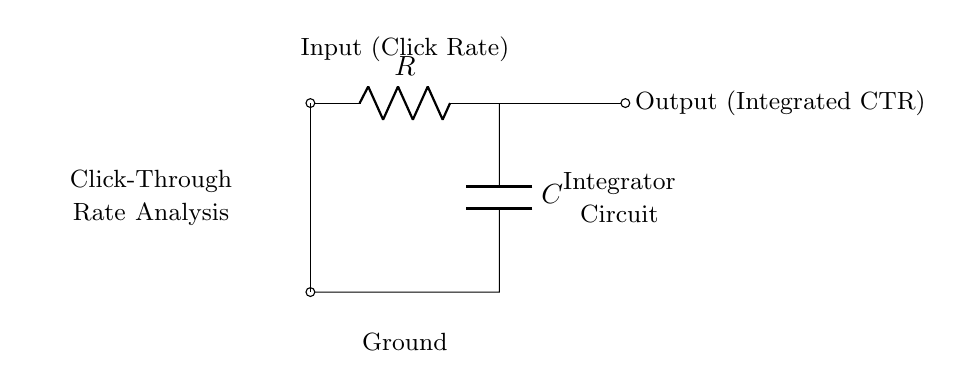What components are present in this circuit? The circuit includes a resistor (R) and a capacitor (C). These are fundamental components used in many electronic circuits, including integrators.
Answer: Resistor and Capacitor What is the function of the circuit shown? This is an integrator circuit; it integrates the input signal (click rate) over time, providing an output that represents the integrated click-through rate. Integrators are used in various applications, including signal processing.
Answer: Integrator What does the input represent in the context of online advertising? The input in this circuit is the click rate, an important metric in digital marketing that indicates the number of clicks relative to the number of impressions. This metric helps assess the effectiveness of an advertising campaign.
Answer: Click Rate What is the output of this integrator circuit? The output is the integrated click-through rate (CTR), which reflects the cumulative clicks over time, thereby providing insight into the performance of the advertisement.
Answer: Integrated CTR How does increasing the resistance (R) affect the output of the circuit? Increasing the resistance (R) in the integrator circuit slows down the charge time of the capacitor (C), which results in a slower response to the input signal. This means the output will take longer to reflect changes in the click rate.
Answer: Slower Response What role does the capacitor (C) play in this circuit? The capacitor (C) is responsible for storing energy and integrating the input signal over time. In this integrator circuit, it captures the voltage changes due to varying click rates and produces an output that reflects this integration.
Answer: Energy Storage What would happen if the capacitor (C) were replaced with an inductor? If the capacitor (C) were replaced with an inductor, the circuit would no longer function as an integrator. Inductors behave differently; they store energy in a magnetic field rather than an electric field, affecting the output response.
Answer: Circuit Function Changes 